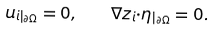<formula> <loc_0><loc_0><loc_500><loc_500>u _ { i | _ { \partial \Omega } } = 0 , \quad \nabla z _ { i } { \cdot } \eta _ { | _ { \partial \Omega } } = 0 .</formula> 